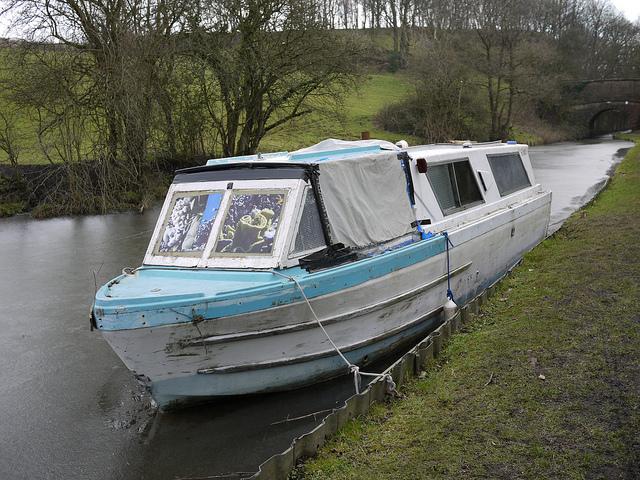How many windows can you see on the boat?
Be succinct. 4. Can you cross the Atlantic in this boat?
Concise answer only. No. Would you consider this a yacht?
Concise answer only. No. 